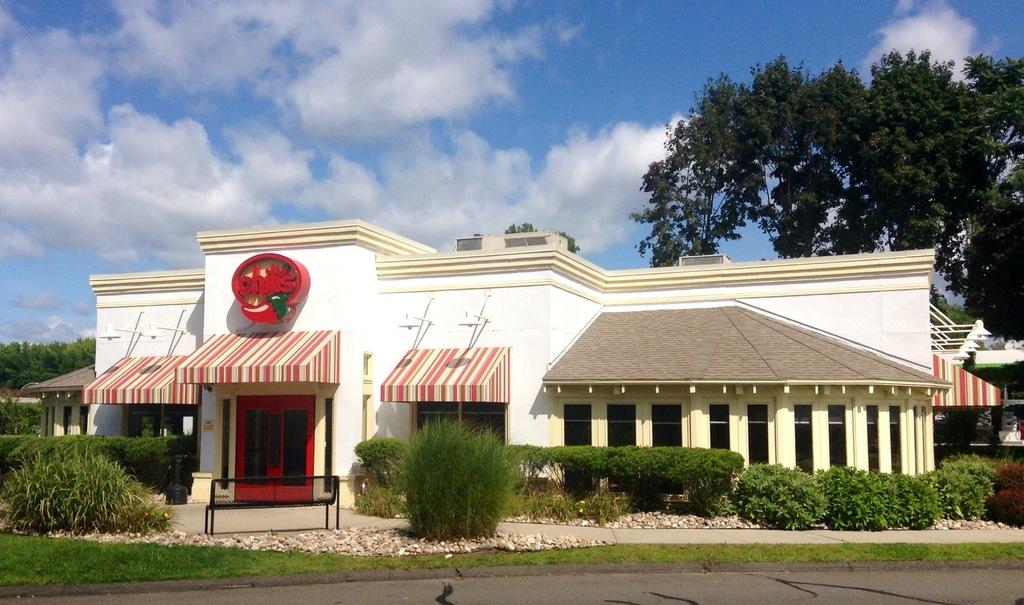Where are you at?
Provide a succinct answer. Chili's. 